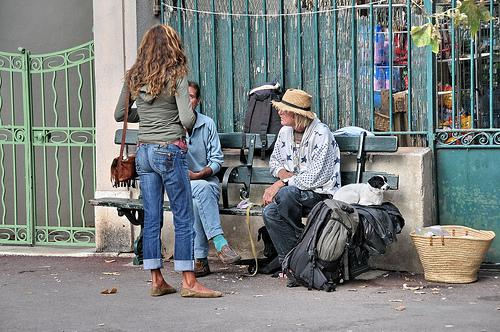Question: why is the woman sitting?
Choices:
A. To rest.
B. Her feet hurt.
C. To wait.
D. To eat.
Answer with the letter. Answer: A Question: what color is the basket?
Choices:
A. Blue.
B. Green.
C. Tan.
D. Orange.
Answer with the letter. Answer: C Question: who is sitting on the bench with a woman?
Choices:
A. A boy.
B. A man.
C. A girl.
D. Another lady.
Answer with the letter. Answer: B Question: how many people are in this picture?
Choices:
A. Three.
B. Four.
C. Five.
D. Six.
Answer with the letter. Answer: A Question: what animal is in this picture?
Choices:
A. Cat.
B. Rabbit.
C. Dog.
D. Raccoon.
Answer with the letter. Answer: C Question: where was this picture taken?
Choices:
A. Under a tree.
B. Outside on sidewalk.
C. Under a canopy.
D. Near a pool.
Answer with the letter. Answer: B 